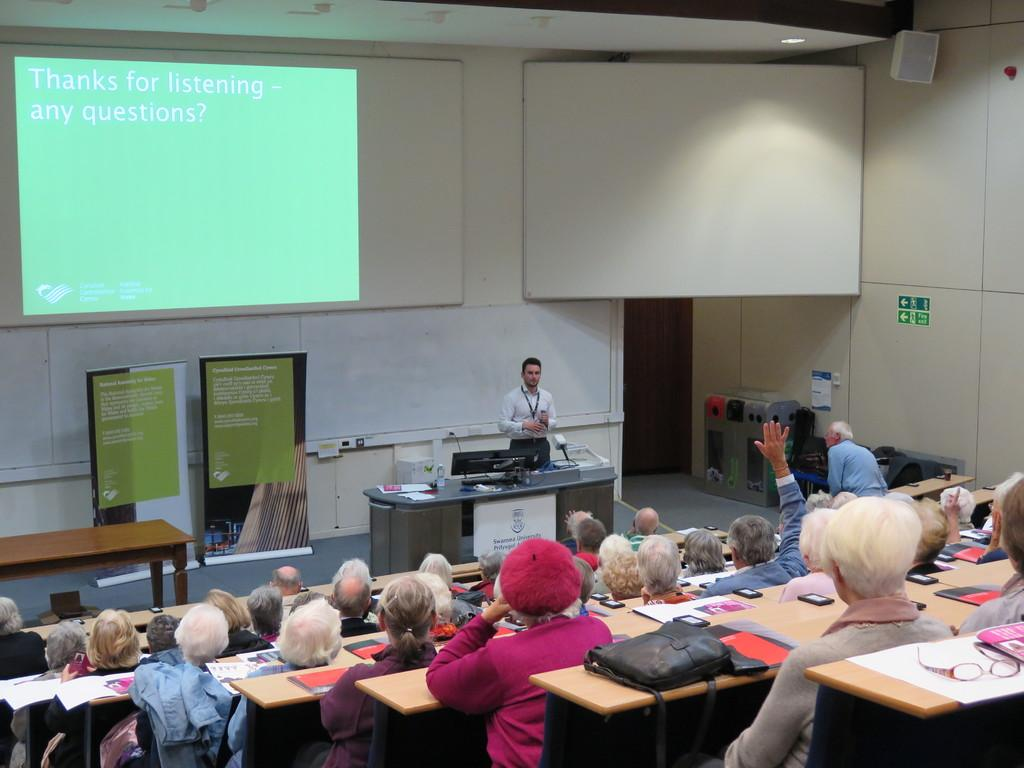What is happening in the image involving a group of people? There is a group of people in the image, and they are sitting on chairs. Where are the chairs located in relation to the table? The chairs are in front of a table. What is the purpose of the projector screen in the image? The projector screen is present in the image, but its purpose is not explicitly stated. What is the man in the image doing? A man is standing in the image. What type of amusement can be seen in the eyes of the people in the image? There is no indication of amusement or any specific emotion in the eyes of the people in the image. Is there a servant present in the image? There is no mention of a servant or any other person assisting the group in the image. 